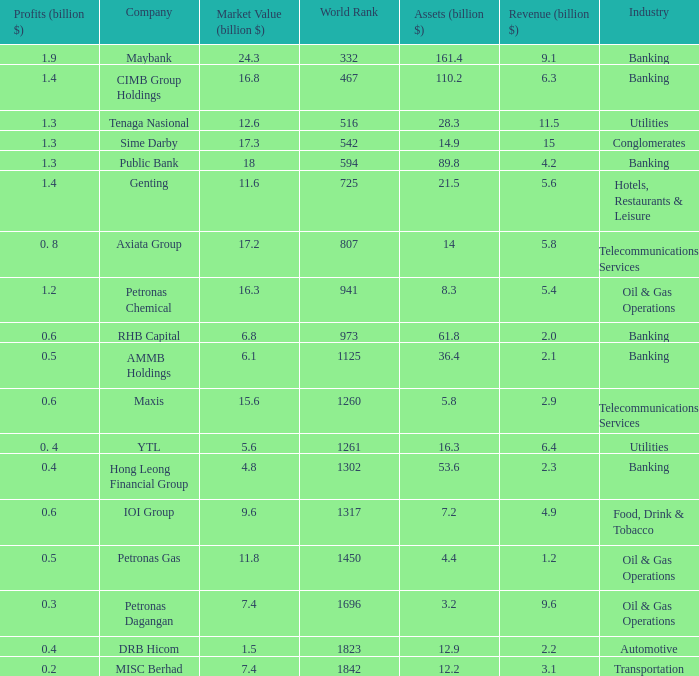Name the market value for rhb capital 6.8. 